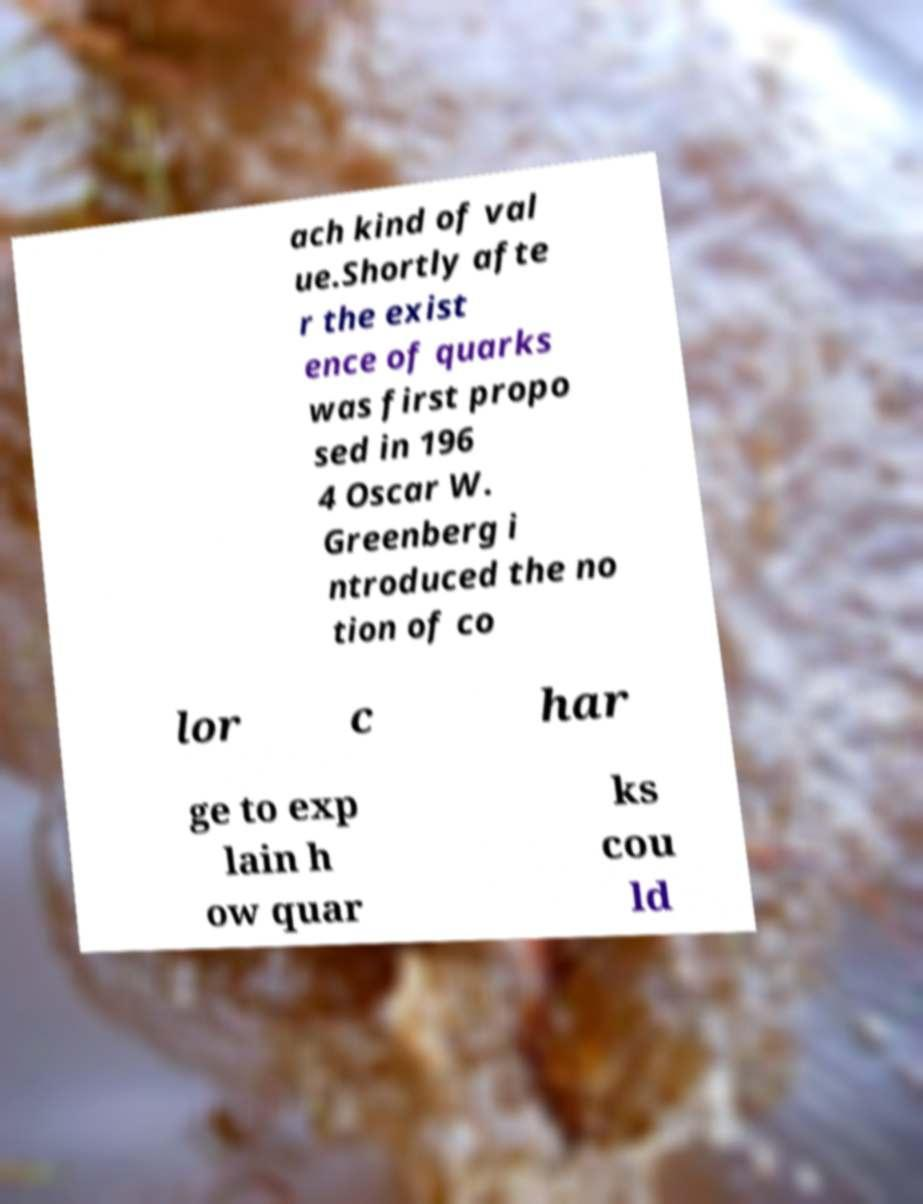What messages or text are displayed in this image? I need them in a readable, typed format. ach kind of val ue.Shortly afte r the exist ence of quarks was first propo sed in 196 4 Oscar W. Greenberg i ntroduced the no tion of co lor c har ge to exp lain h ow quar ks cou ld 